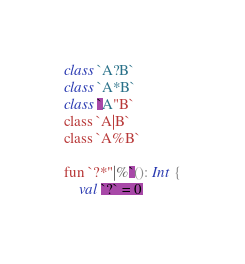Convert code to text. <code><loc_0><loc_0><loc_500><loc_500><_Kotlin_>class `A?B`
class `A*B`
class `A"B`
class `A|B`
class `A%B`

fun `?*"|%`(): Int {
    val `?` = 0</code> 